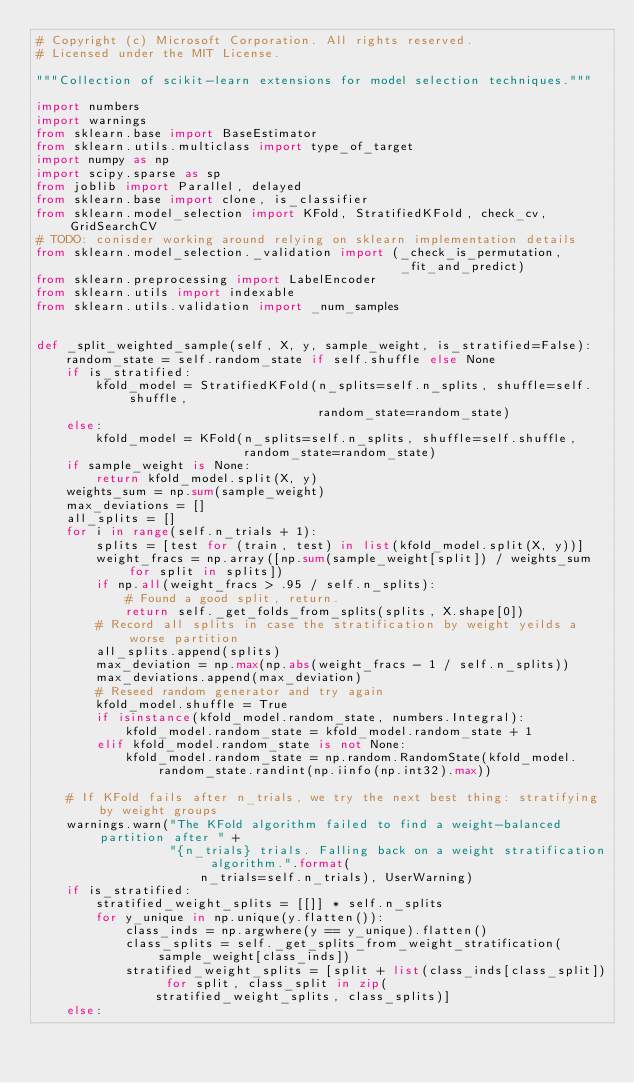Convert code to text. <code><loc_0><loc_0><loc_500><loc_500><_Python_># Copyright (c) Microsoft Corporation. All rights reserved.
# Licensed under the MIT License.

"""Collection of scikit-learn extensions for model selection techniques."""

import numbers
import warnings
from sklearn.base import BaseEstimator
from sklearn.utils.multiclass import type_of_target
import numpy as np
import scipy.sparse as sp
from joblib import Parallel, delayed
from sklearn.base import clone, is_classifier
from sklearn.model_selection import KFold, StratifiedKFold, check_cv, GridSearchCV
# TODO: conisder working around relying on sklearn implementation details
from sklearn.model_selection._validation import (_check_is_permutation,
                                                 _fit_and_predict)
from sklearn.preprocessing import LabelEncoder
from sklearn.utils import indexable
from sklearn.utils.validation import _num_samples


def _split_weighted_sample(self, X, y, sample_weight, is_stratified=False):
    random_state = self.random_state if self.shuffle else None
    if is_stratified:
        kfold_model = StratifiedKFold(n_splits=self.n_splits, shuffle=self.shuffle,
                                      random_state=random_state)
    else:
        kfold_model = KFold(n_splits=self.n_splits, shuffle=self.shuffle,
                            random_state=random_state)
    if sample_weight is None:
        return kfold_model.split(X, y)
    weights_sum = np.sum(sample_weight)
    max_deviations = []
    all_splits = []
    for i in range(self.n_trials + 1):
        splits = [test for (train, test) in list(kfold_model.split(X, y))]
        weight_fracs = np.array([np.sum(sample_weight[split]) / weights_sum for split in splits])
        if np.all(weight_fracs > .95 / self.n_splits):
            # Found a good split, return.
            return self._get_folds_from_splits(splits, X.shape[0])
        # Record all splits in case the stratification by weight yeilds a worse partition
        all_splits.append(splits)
        max_deviation = np.max(np.abs(weight_fracs - 1 / self.n_splits))
        max_deviations.append(max_deviation)
        # Reseed random generator and try again
        kfold_model.shuffle = True
        if isinstance(kfold_model.random_state, numbers.Integral):
            kfold_model.random_state = kfold_model.random_state + 1
        elif kfold_model.random_state is not None:
            kfold_model.random_state = np.random.RandomState(kfold_model.random_state.randint(np.iinfo(np.int32).max))

    # If KFold fails after n_trials, we try the next best thing: stratifying by weight groups
    warnings.warn("The KFold algorithm failed to find a weight-balanced partition after " +
                  "{n_trials} trials. Falling back on a weight stratification algorithm.".format(
                      n_trials=self.n_trials), UserWarning)
    if is_stratified:
        stratified_weight_splits = [[]] * self.n_splits
        for y_unique in np.unique(y.flatten()):
            class_inds = np.argwhere(y == y_unique).flatten()
            class_splits = self._get_splits_from_weight_stratification(sample_weight[class_inds])
            stratified_weight_splits = [split + list(class_inds[class_split]) for split, class_split in zip(
                stratified_weight_splits, class_splits)]
    else:</code> 